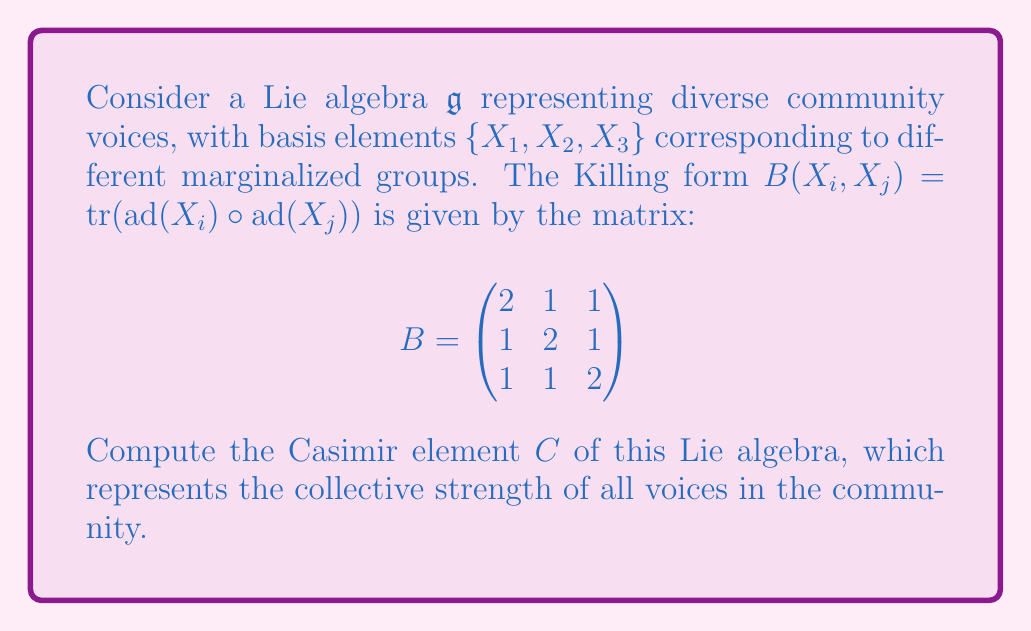Could you help me with this problem? To compute the Casimir element, we follow these steps:

1) First, we need to find the inverse of the Killing form matrix $B$. We can compute this inverse:

   $$B^{-1} = \frac{1}{4}\begin{pmatrix}
   3 & -1 & -1 \\
   -1 & 3 & -1 \\
   -1 & -1 & 3
   \end{pmatrix}$$

2) The Casimir element is defined as:

   $$C = \sum_{i,j} (B^{-1})_{ij} X_i X_j$$

   where $(B^{-1})_{ij}$ are the entries of the inverse Killing form matrix.

3) Expanding this sum:

   $$C = \frac{1}{4}(3X_1X_1 - X_1X_2 - X_1X_3 - X_2X_1 + 3X_2X_2 - X_2X_3 - X_3X_1 - X_3X_2 + 3X_3X_3)$$

4) In a Lie algebra, we have $X_iX_j - X_jX_i = [X_i, X_j]$. Using this, we can rewrite our expression:

   $$C = \frac{1}{4}(3X_1X_1 + 3X_2X_2 + 3X_3X_3 - [X_1,X_2] - [X_1,X_3] - [X_2,X_3])$$

5) The Casimir element is always in the center of the Lie algebra, meaning it commutes with all elements. This property is reflected in this final form.
Answer: The Casimir element is:

$$C = \frac{1}{4}(3X_1X_1 + 3X_2X_2 + 3X_3X_3 - [X_1,X_2] - [X_1,X_3] - [X_2,X_3])$$ 